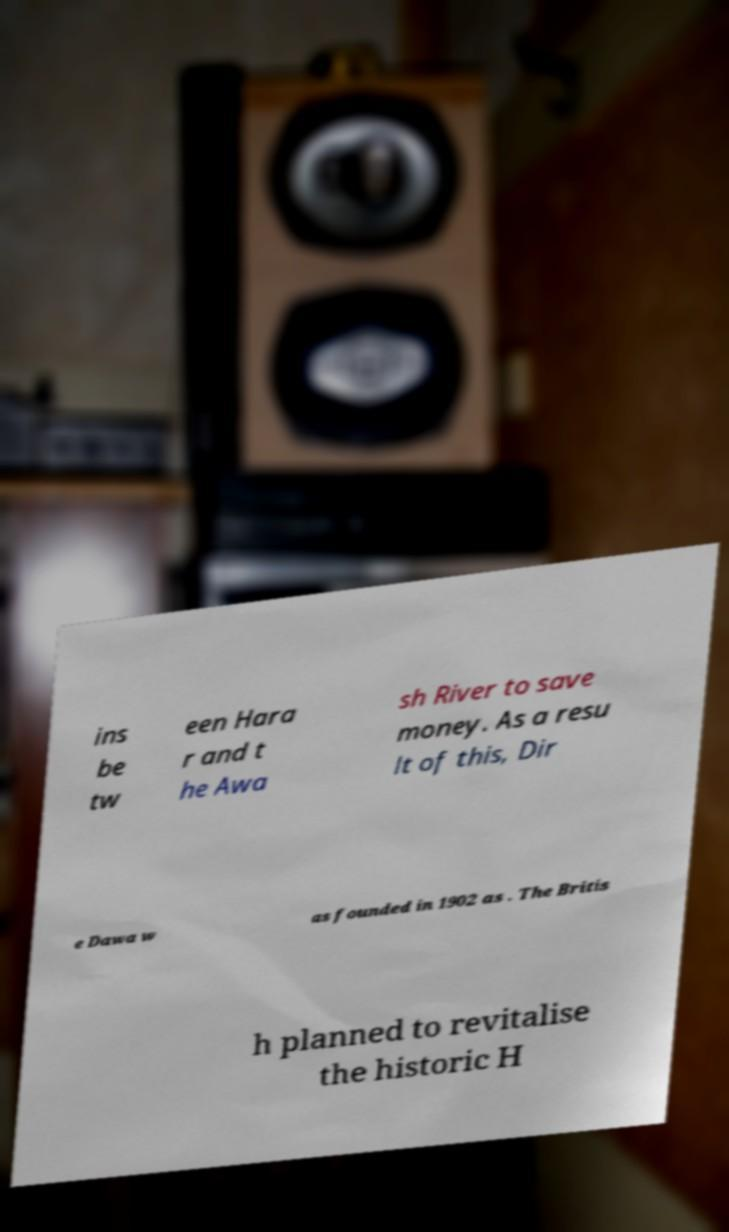For documentation purposes, I need the text within this image transcribed. Could you provide that? ins be tw een Hara r and t he Awa sh River to save money. As a resu lt of this, Dir e Dawa w as founded in 1902 as . The Britis h planned to revitalise the historic H 